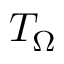Convert formula to latex. <formula><loc_0><loc_0><loc_500><loc_500>T _ { \Omega }</formula> 